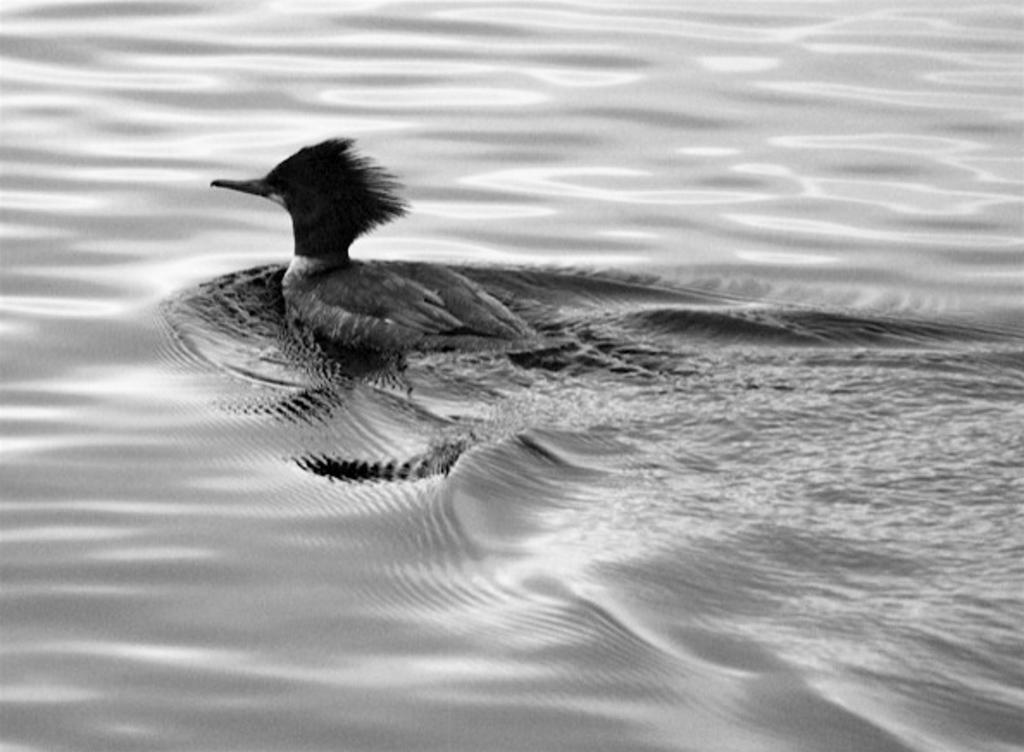What type of animal is in the image? There is a bird in the image. Where is the bird located in the image? The bird is in the water. What type of smile can be seen on the bird's face in the image? There is no smile visible on the bird's face in the image, as birds do not have facial expressions like humans. 